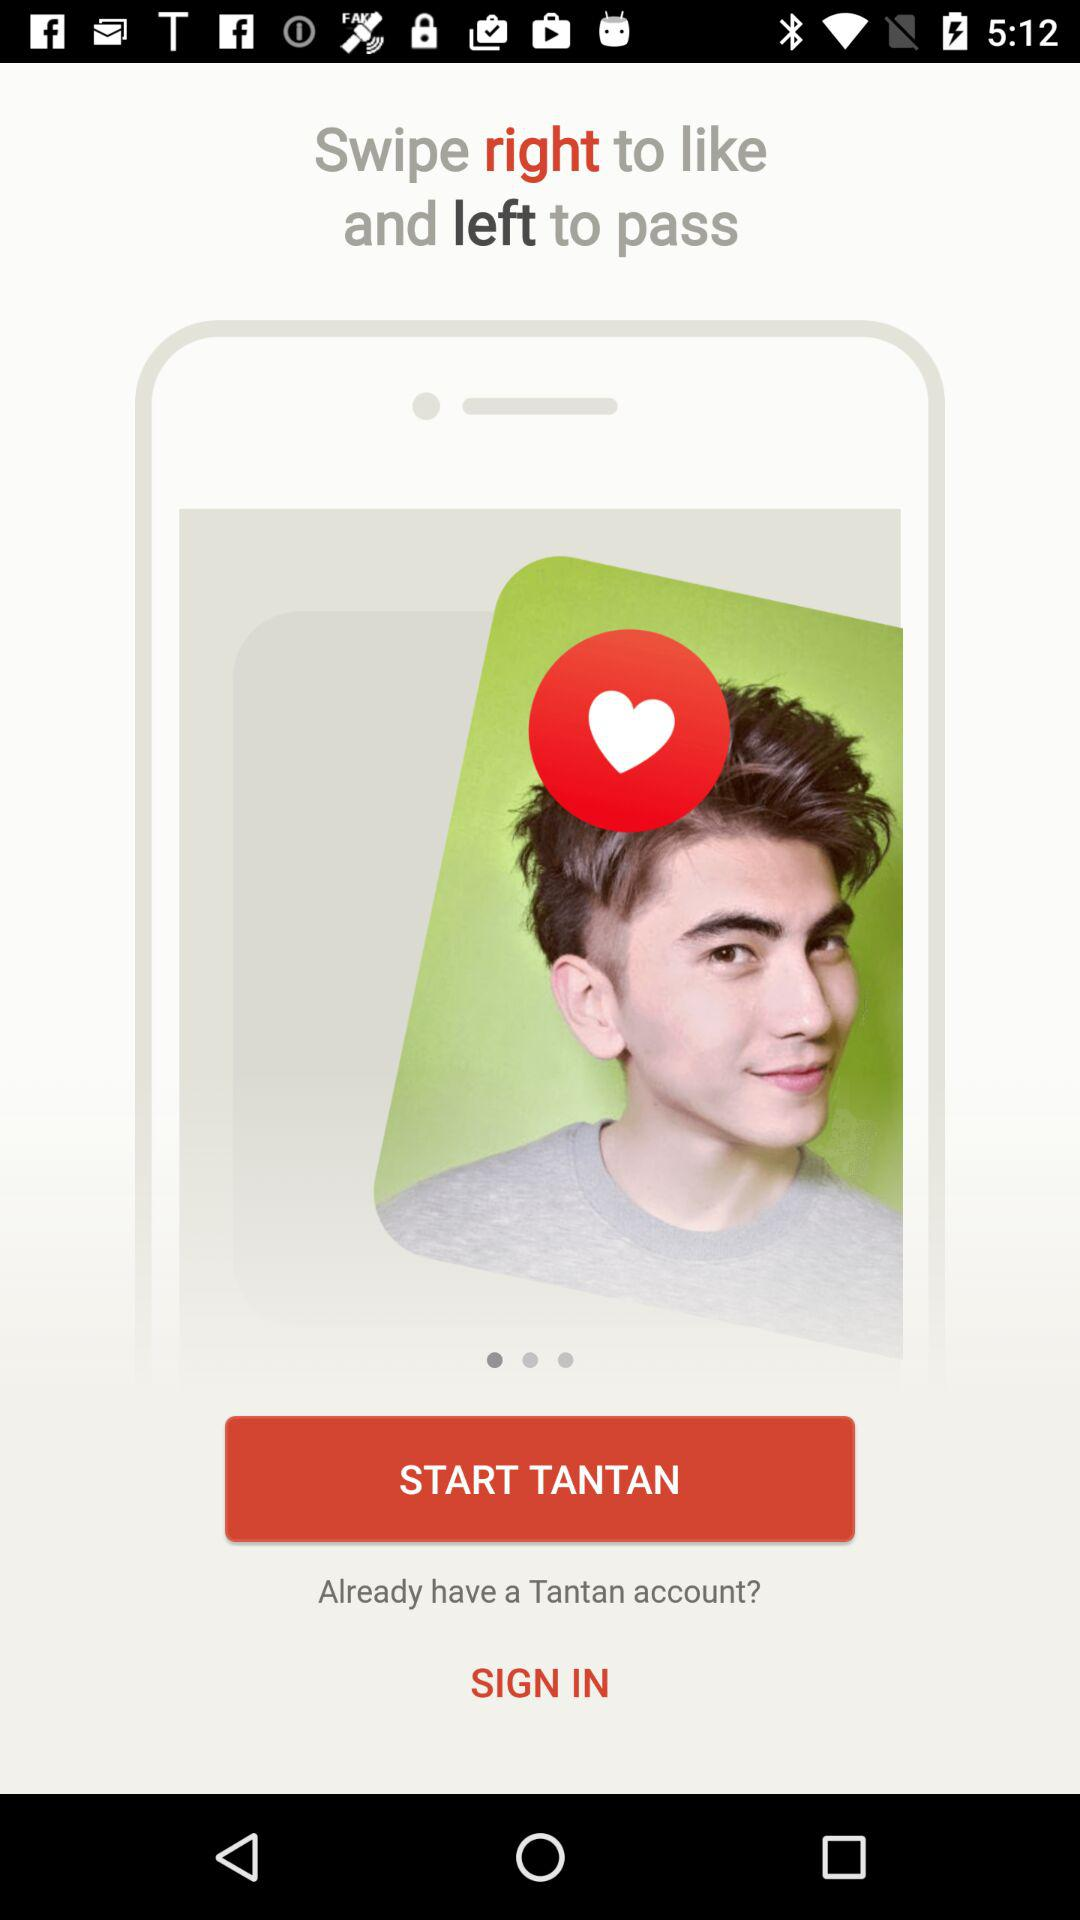What is the application name? The application name is "Tantan". 